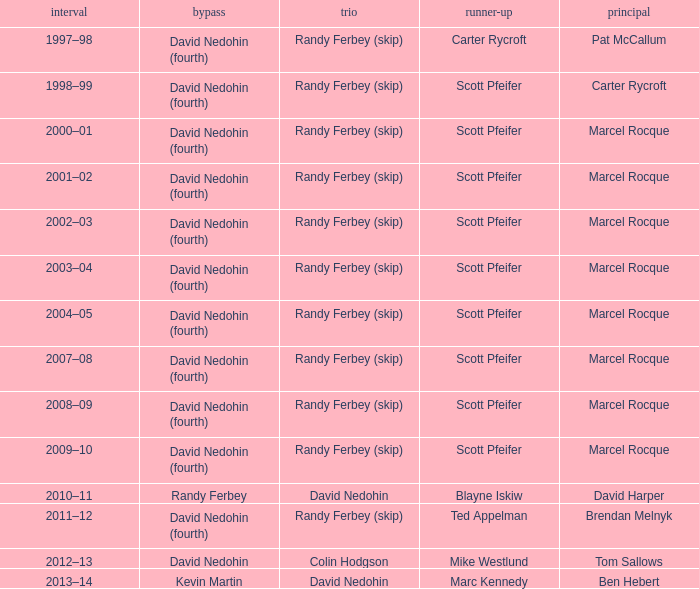Which Second has a Third of david nedohin, and a Lead of ben hebert? Marc Kennedy. 